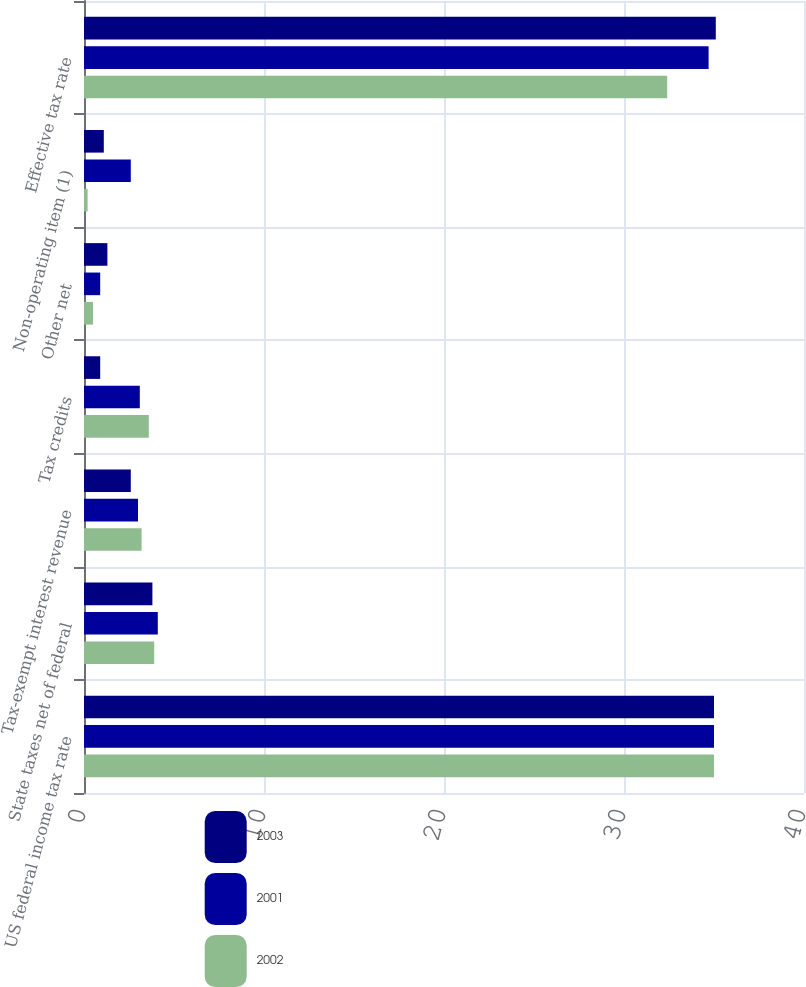Convert chart to OTSL. <chart><loc_0><loc_0><loc_500><loc_500><stacked_bar_chart><ecel><fcel>US federal income tax rate<fcel>State taxes net of federal<fcel>Tax-exempt interest revenue<fcel>Tax credits<fcel>Other net<fcel>Non-operating item (1)<fcel>Effective tax rate<nl><fcel>2003<fcel>35<fcel>3.8<fcel>2.6<fcel>0.9<fcel>1.3<fcel>1.1<fcel>35.1<nl><fcel>2001<fcel>35<fcel>4.1<fcel>3<fcel>3.1<fcel>0.9<fcel>2.6<fcel>34.7<nl><fcel>2002<fcel>35<fcel>3.9<fcel>3.2<fcel>3.6<fcel>0.5<fcel>0.2<fcel>32.4<nl></chart> 